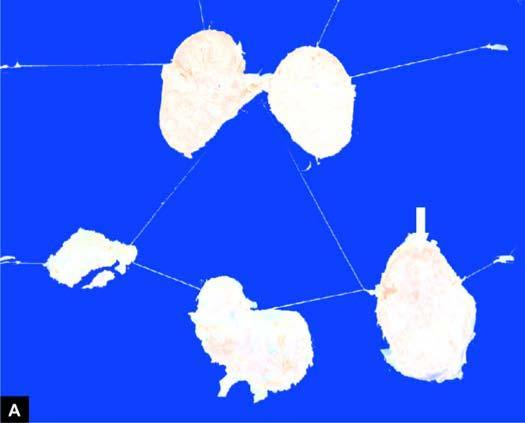what shows merging capsules and large areas of caseation necrosis?
Answer the question using a single word or phrase. Section of matted mass 